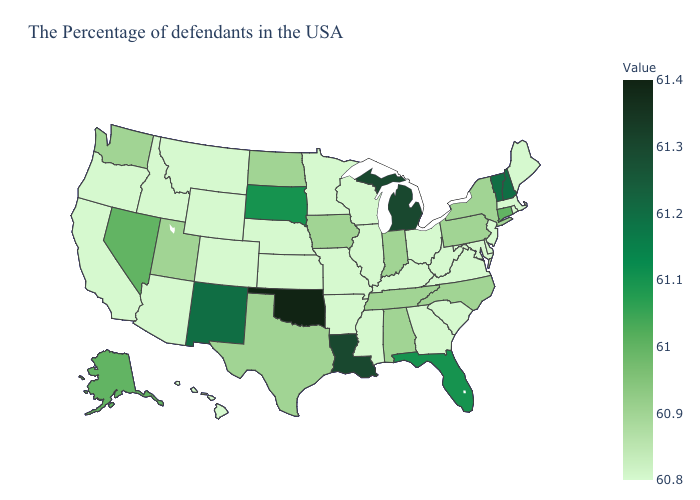Which states have the lowest value in the USA?
Be succinct. Maine, Massachusetts, Rhode Island, New Jersey, Delaware, Maryland, Virginia, South Carolina, West Virginia, Ohio, Georgia, Kentucky, Wisconsin, Illinois, Mississippi, Missouri, Arkansas, Minnesota, Kansas, Nebraska, Wyoming, Colorado, Montana, Arizona, Idaho, California, Oregon, Hawaii. Which states have the highest value in the USA?
Write a very short answer. Oklahoma. Among the states that border Oklahoma , does Kansas have the highest value?
Be succinct. No. Does Oregon have the highest value in the West?
Quick response, please. No. Which states hav the highest value in the Northeast?
Write a very short answer. New Hampshire, Vermont. Does Vermont have the highest value in the USA?
Give a very brief answer. No. Which states have the highest value in the USA?
Answer briefly. Oklahoma. Does Wyoming have the highest value in the West?
Short answer required. No. Does Kentucky have the highest value in the USA?
Keep it brief. No. 